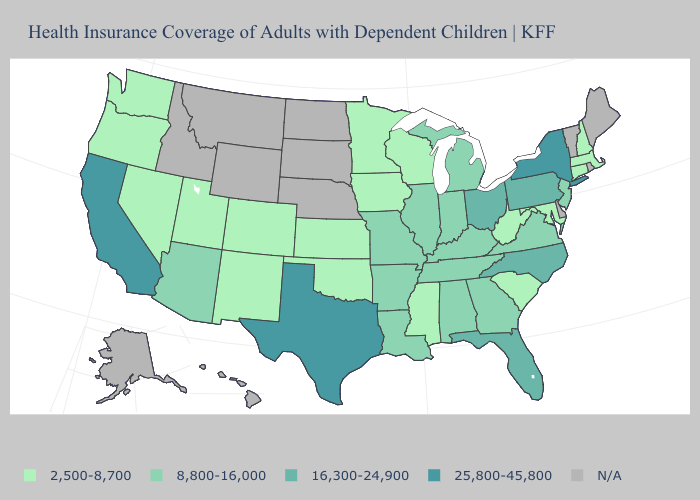How many symbols are there in the legend?
Answer briefly. 5. Among the states that border Utah , which have the highest value?
Keep it brief. Arizona. Which states have the lowest value in the South?
Quick response, please. Maryland, Mississippi, Oklahoma, South Carolina, West Virginia. Name the states that have a value in the range N/A?
Be succinct. Alaska, Delaware, Hawaii, Idaho, Maine, Montana, Nebraska, North Dakota, Rhode Island, South Dakota, Vermont, Wyoming. What is the value of West Virginia?
Quick response, please. 2,500-8,700. What is the value of Colorado?
Give a very brief answer. 2,500-8,700. Which states have the lowest value in the USA?
Short answer required. Colorado, Connecticut, Iowa, Kansas, Maryland, Massachusetts, Minnesota, Mississippi, Nevada, New Hampshire, New Mexico, Oklahoma, Oregon, South Carolina, Utah, Washington, West Virginia, Wisconsin. What is the value of Idaho?
Be succinct. N/A. Among the states that border Virginia , which have the highest value?
Be succinct. North Carolina. Which states hav the highest value in the West?
Answer briefly. California. What is the value of Colorado?
Keep it brief. 2,500-8,700. What is the value of Iowa?
Short answer required. 2,500-8,700. Does New York have the highest value in the Northeast?
Give a very brief answer. Yes. Which states hav the highest value in the South?
Give a very brief answer. Texas. Name the states that have a value in the range N/A?
Write a very short answer. Alaska, Delaware, Hawaii, Idaho, Maine, Montana, Nebraska, North Dakota, Rhode Island, South Dakota, Vermont, Wyoming. 